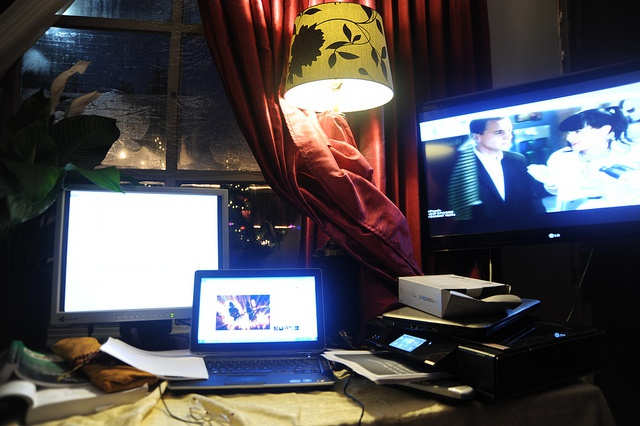Describe the objects in this image and their specific colors. I can see tv in black, white, navy, blue, and darkblue tones, tv in black, white, gray, and navy tones, laptop in black, white, navy, blue, and darkblue tones, tv in black, white, darkblue, blue, and navy tones, and people in black, white, blue, and lightblue tones in this image. 